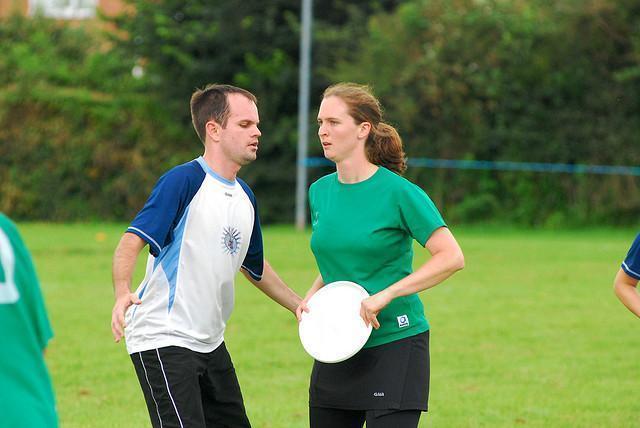The man in blue wants to do what to the frisbee holder?
From the following set of four choices, select the accurate answer to respond to the question.
Options: Assist her, block her, nothing, embarrass her. Block her. 